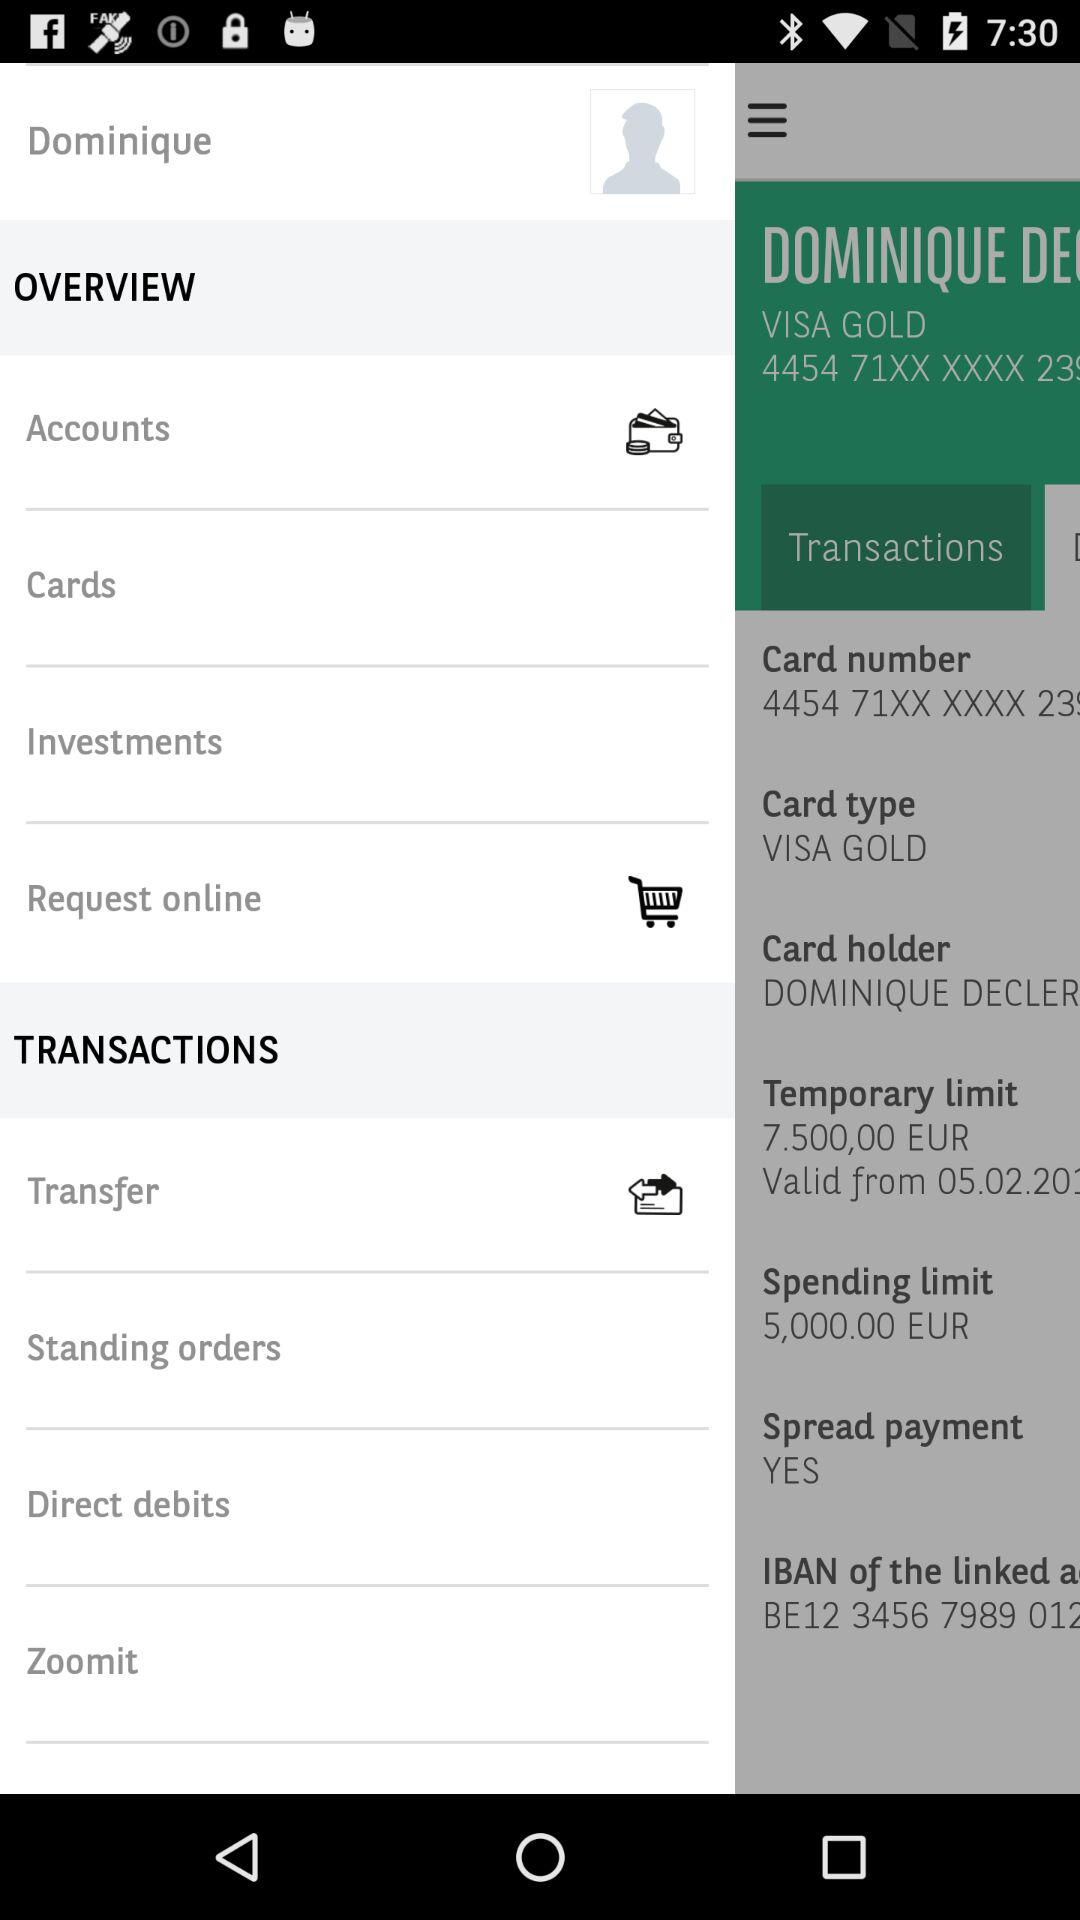What is the amount of the spending limit?
Answer the question using a single word or phrase. 5,000.00 EUR 